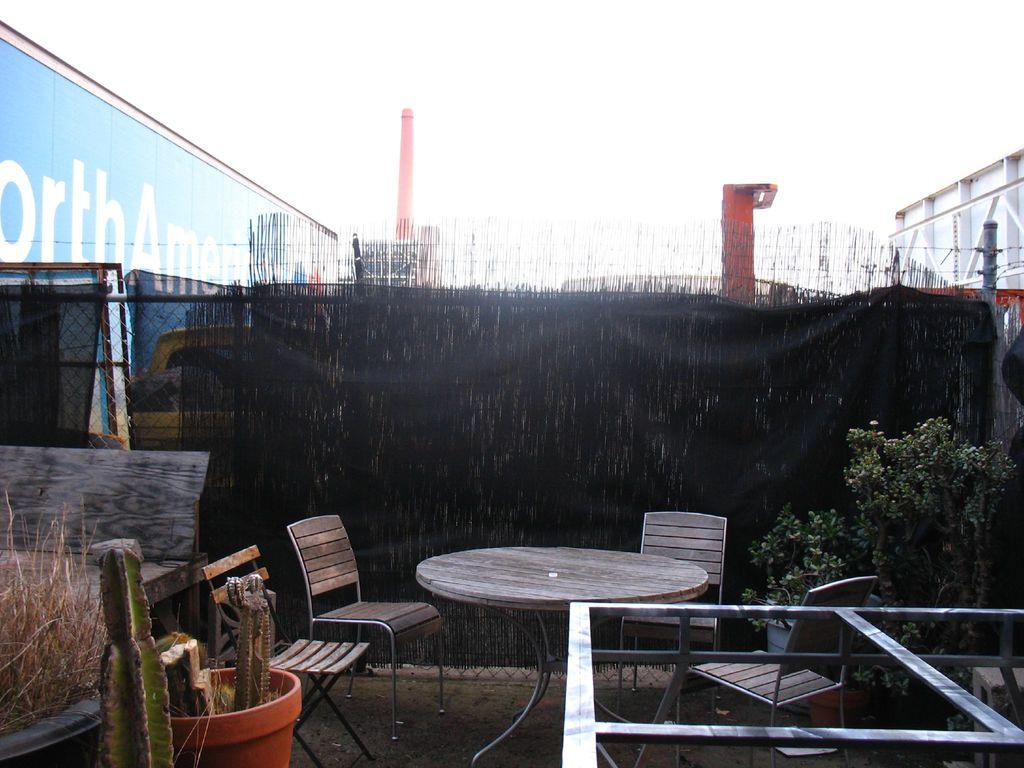What type of table is in the image? There is a wooden table in the image. What is the seating arrangement around the table? There are wooden chairs around the table. What can be seen in the right corner of the image? There is a tree in the right corner of the image. What type of need is being fulfilled by the presence of the tree in the image? The image does not provide information about the need being fulfilled by the presence of the tree. 